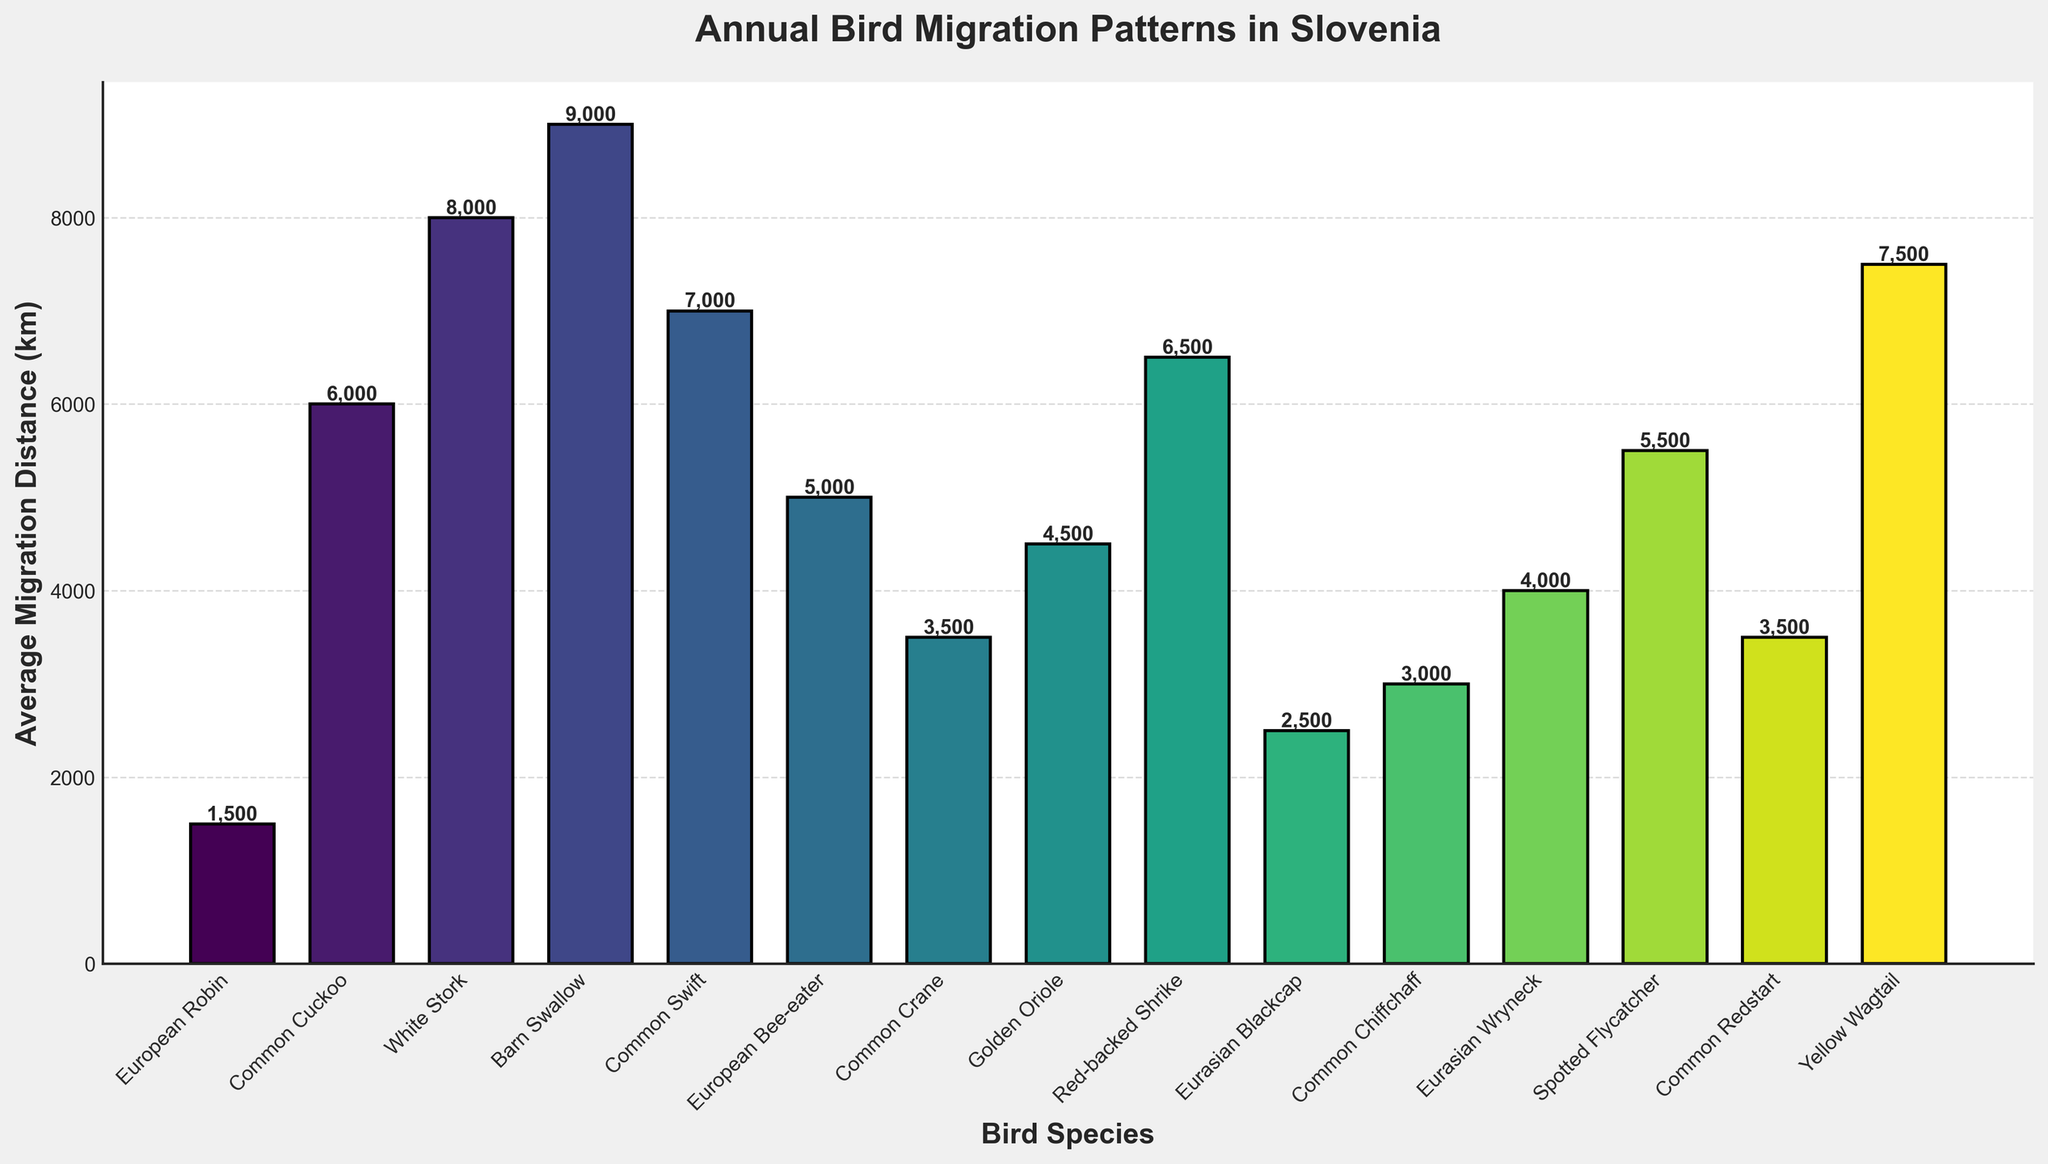What is the bird species with the longest average migration distance? The plot shows the average migration distances for various bird species. Identify the bar with the highest value. The Barn Swallow has the longest distance at 9000 km.
Answer: Barn Swallow Which bird species migrate more than 7000 km annually? Review the bars that exceed the 7000 km mark. The Barn Swallow (9000 km), White Stork (8000 km), Common Swift (7000 km), and Yellow Wagtail (7500 km) all migrate more than 7000 km annually.
Answer: Barn Swallow, White Stork, Common Swift, Yellow Wagtail How much greater is the European Robin's migration distance compared to the Eurasian Blackcap? Identify the bars for the European Robin (1500 km) and the Eurasian Blackcap (2500 km), then subtract the smaller from the larger: 2500 km - 1500 km = 1000 km. The European Robin's distance is 1000 km less than the Eurasian Blackcap's.
Answer: 1000 km less What is the average migration distance of the Common Cuckoo, European Bee-eater, and Red-backed Shrike combined? First, sum their distances: 6000 km (Common Cuckoo) + 5000 km (European Bee-eater) + 6500 km (Red-backed Shrike) = 17500 km. Then, divide by the number of species: 17500 km / 3 = 5833.33 km.
Answer: 5833.33 km Between the Common Crane and the Spotted Flycatcher, which has a higher average migration distance? Locate the bars for the Common Crane (3500 km) and the Spotted Flycatcher (5500 km) and compare their heights. The Spotted Flycatcher has a higher migration distance.
Answer: Spotted Flycatcher How many species have an average migration distance between 4000 km and 7000 km? Identify bars within the range of 4000 km to 7000 km: Eurasian Wryneck (4000 km), Golden Oriole (4500 km), Spotted Flycatcher (5500 km), European Bee-eater (5000 km), Red-backed Shrike (6500 km), and Common Swift (7000 km). Count these bars, which total six species.
Answer: 6 species What is the total migration distance for the birds with the three shortest average migration distances? Identify the three species with the shortest bars: European Robin (1500 km), Eurasian Blackcap (2500 km), and Common Chiffchaff (3000 km). Add these distances: 1500 km + 2500 km + 3000 km = 7000 km.
Answer: 7000 km Which bird migrates farther: the Common Swift or the Golden Oriole? Locate and compare the bars of the Common Swift (7000 km) and the Golden Oriole (4500 km). The Common Swift migrates farther.
Answer: Common Swift What is the range of migration distances (difference between the maximum and minimum distances) among the species in the figure? Identify the maximum distance (Barn Swallow at 9000 km) and the minimum distance (European Robin at 1500 km), then subtract: 9000 km - 1500 km = 7500 km.
Answer: 7500 km Which bird species have a migration distance closest to 4000 km? Identify the species with a bar corresponding to 4000 km. The Eurasian Wryneck has the closest average migration distance, exactly 4000 km.
Answer: Eurasian Wryneck 